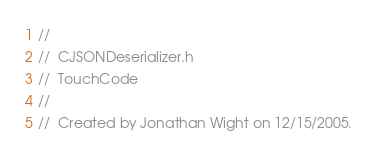<code> <loc_0><loc_0><loc_500><loc_500><_C_>//
//  CJSONDeserializer.h
//  TouchCode
//
//  Created by Jonathan Wight on 12/15/2005.</code> 